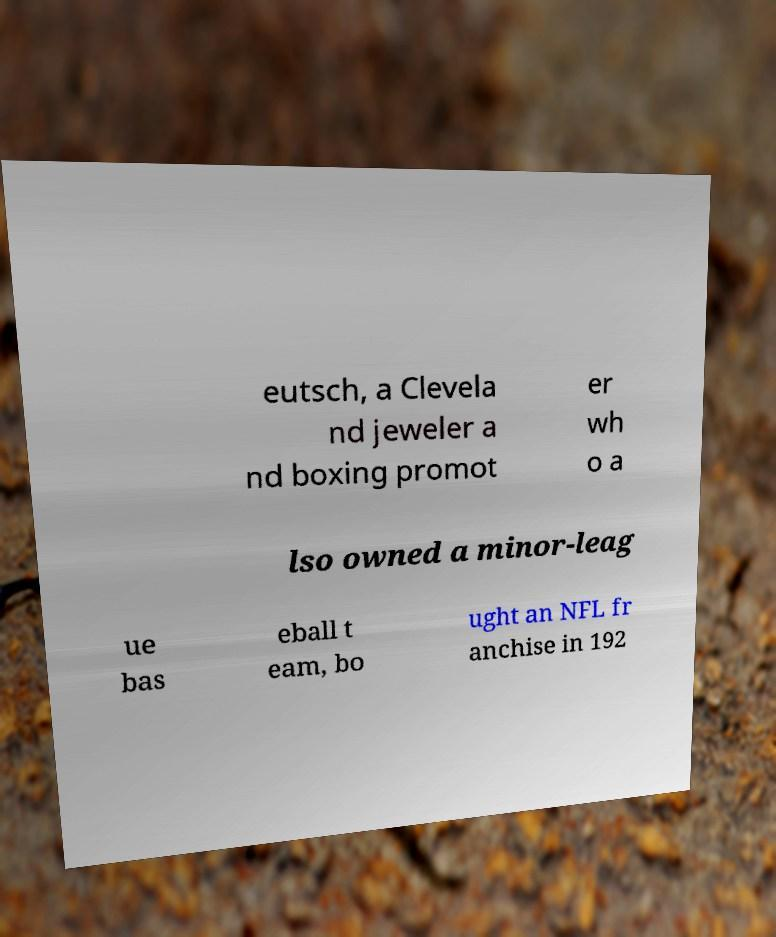What messages or text are displayed in this image? I need them in a readable, typed format. eutsch, a Clevela nd jeweler a nd boxing promot er wh o a lso owned a minor-leag ue bas eball t eam, bo ught an NFL fr anchise in 192 